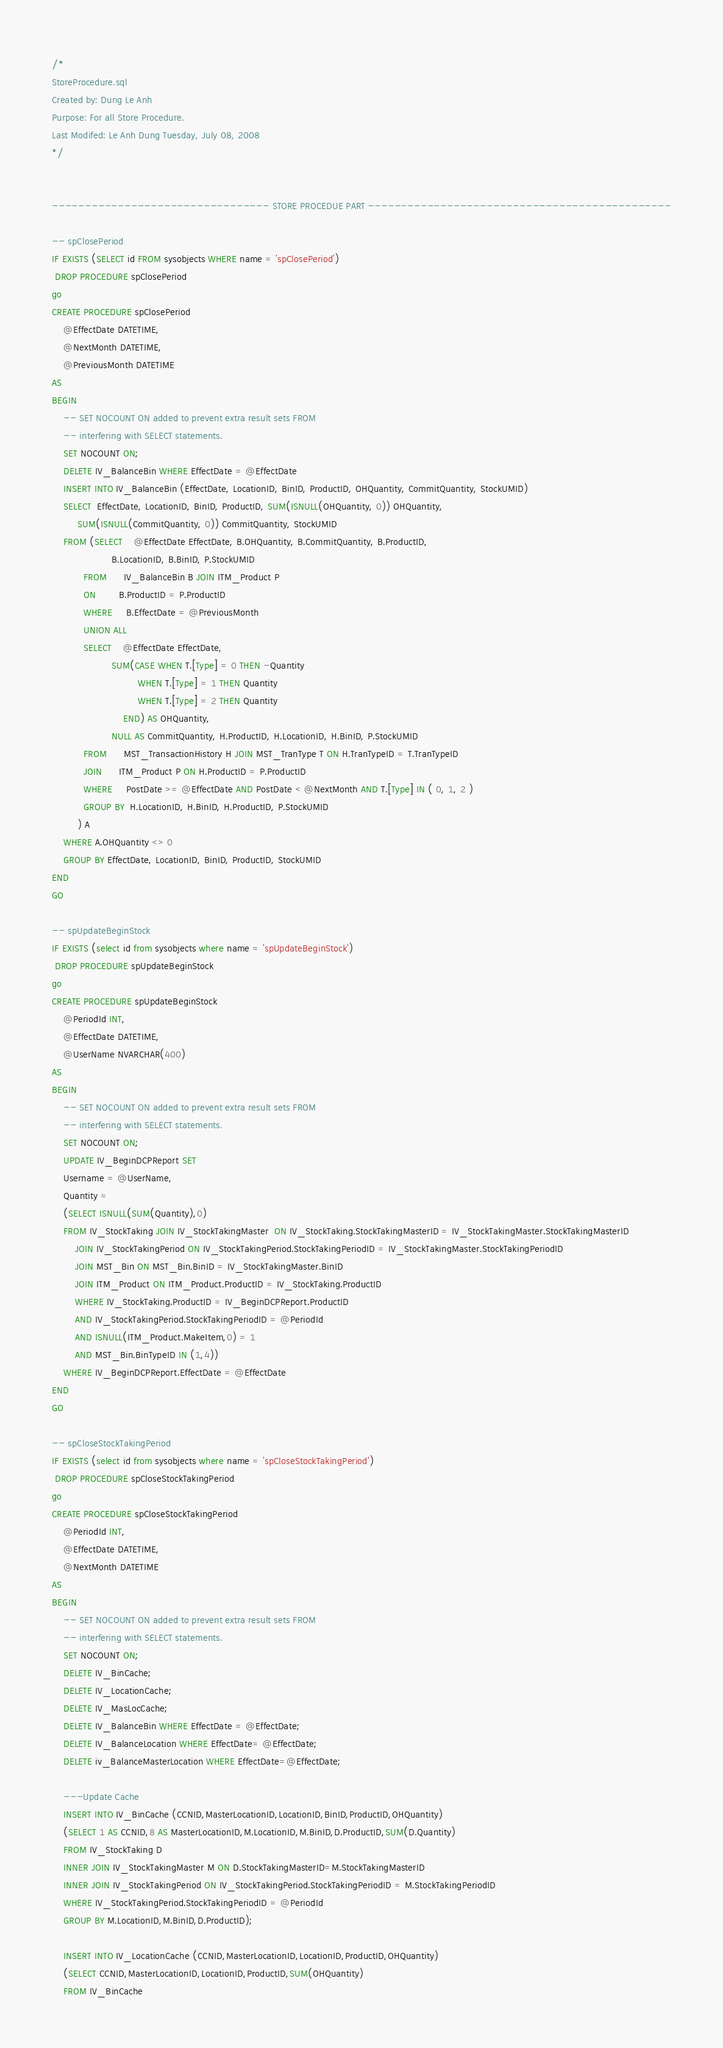<code> <loc_0><loc_0><loc_500><loc_500><_SQL_>/*
StoreProcedure.sql
Created by: Dung Le Anh
Purpose: For all Store Procedure.
Last Modifed: Le Anh Dung Tuesday, July 08, 2008
*/


--------------------------------- STORE PROCEDUE PART ----------------------------------------------

-- spClosePeriod
IF EXISTS (SELECT id FROM sysobjects WHERE name = 'spClosePeriod')
 DROP PROCEDURE spClosePeriod
go
CREATE PROCEDURE spClosePeriod
	@EffectDate DATETIME,
	@NextMonth DATETIME,
	@PreviousMonth DATETIME
AS
BEGIN
	-- SET NOCOUNT ON added to prevent extra result sets FROM
	-- interfering with SELECT statements.
	SET NOCOUNT ON;
	DELETE IV_BalanceBin WHERE EffectDate = @EffectDate
	INSERT INTO IV_BalanceBin (EffectDate, LocationID, BinID, ProductID, OHQuantity, CommitQuantity, StockUMID)
	SELECT  EffectDate, LocationID, BinID, ProductID, SUM(ISNULL(OHQuantity, 0)) OHQuantity,
         SUM(ISNULL(CommitQuantity, 0)) CommitQuantity, StockUMID
    FROM (SELECT    @EffectDate EffectDate, B.OHQuantity, B.CommitQuantity, B.ProductID,
                     B.LocationID, B.BinID, P.StockUMID
           FROM      IV_BalanceBin B JOIN ITM_Product P
           ON        B.ProductID = P.ProductID
           WHERE     B.EffectDate = @PreviousMonth
           UNION ALL
           SELECT    @EffectDate EffectDate,
                     SUM(CASE WHEN T.[Type] = 0 THEN -Quantity
                              WHEN T.[Type] = 1 THEN Quantity
                              WHEN T.[Type] = 2 THEN Quantity
                         END) AS OHQuantity,
                     NULL AS CommitQuantity, H.ProductID, H.LocationID, H.BinID, P.StockUMID
           FROM      MST_TransactionHistory H JOIN MST_TranType T ON H.TranTypeID = T.TranTypeID
           JOIN      ITM_Product P ON H.ProductID = P.ProductID
           WHERE     PostDate >= @EffectDate AND PostDate < @NextMonth AND T.[Type] IN ( 0, 1, 2 )
           GROUP BY  H.LocationID, H.BinID, H.ProductID, P.StockUMID
         ) A
	WHERE A.OHQuantity <> 0
	GROUP BY EffectDate, LocationID, BinID, ProductID, StockUMID
END
GO

-- spUpdateBeginStock
IF EXISTS (select id from sysobjects where name = 'spUpdateBeginStock')
 DROP PROCEDURE spUpdateBeginStock
go
CREATE PROCEDURE spUpdateBeginStock
	@PeriodId INT,
	@EffectDate DATETIME,
	@UserName NVARCHAR(400)
AS
BEGIN
	-- SET NOCOUNT ON added to prevent extra result sets FROM
	-- interfering with SELECT statements.
	SET NOCOUNT ON;
	UPDATE IV_BeginDCPReport SET
	Username = @UserName,
	Quantity =
	(SELECT ISNULL(SUM(Quantity),0)
	FROM IV_StockTaking JOIN IV_StockTakingMaster  ON IV_StockTaking.StockTakingMasterID = IV_StockTakingMaster.StockTakingMasterID
		JOIN IV_StockTakingPeriod ON IV_StockTakingPeriod.StockTakingPeriodID = IV_StockTakingMaster.StockTakingPeriodID
		JOIN MST_Bin ON MST_Bin.BinID = IV_StockTakingMaster.BinID
		JOIN ITM_Product ON ITM_Product.ProductID = IV_StockTaking.ProductID
		WHERE IV_StockTaking.ProductID = IV_BeginDCPReport.ProductID
		AND IV_StockTakingPeriod.StockTakingPeriodID = @PeriodId
		AND ISNULL(ITM_Product.MakeItem,0) = 1
		AND MST_Bin.BinTypeID IN (1,4))
	WHERE IV_BeginDCPReport.EffectDate = @EffectDate
END
GO

-- spCloseStockTakingPeriod
IF EXISTS (select id from sysobjects where name = 'spCloseStockTakingPeriod')
 DROP PROCEDURE spCloseStockTakingPeriod
go
CREATE PROCEDURE spCloseStockTakingPeriod
	@PeriodId INT,
	@EffectDate DATETIME,
	@NextMonth DATETIME
AS
BEGIN
	-- SET NOCOUNT ON added to prevent extra result sets FROM
	-- interfering with SELECT statements.
	SET NOCOUNT ON;
	DELETE IV_BinCache;
	DELETE IV_LocationCache;
	DELETE IV_MasLocCache;
	DELETE IV_BalanceBin WHERE EffectDate = @EffectDate;
	DELETE IV_BalanceLocation WHERE EffectDate= @EffectDate;
	DELETE iv_BalanceMasterLocation WHERE EffectDate=@EffectDate;
	
	---Update Cache
	INSERT INTO IV_BinCache (CCNID,MasterLocationID,LocationID,BinID,ProductID,OHQuantity)
	(SELECT 1 AS CCNID,8 AS MasterLocationID,M.LocationID,M.BinID,D.ProductID,SUM(D.Quantity)
	FROM IV_StockTaking D
	INNER JOIN IV_StockTakingMaster M ON D.StockTakingMasterID=M.StockTakingMasterID
	INNER JOIN IV_StockTakingPeriod ON IV_StockTakingPeriod.StockTakingPeriodID = M.StockTakingPeriodID
	WHERE IV_StockTakingPeriod.StockTakingPeriodID = @PeriodId
	GROUP BY M.LocationID,M.BinID,D.ProductID);

	INSERT INTO IV_LocationCache (CCNID,MasterLocationID,LocationID,ProductID,OHQuantity)
	(SELECT CCNID,MasterLocationID,LocationID,ProductID,SUM(OHQuantity)
	FROM IV_BinCache</code> 